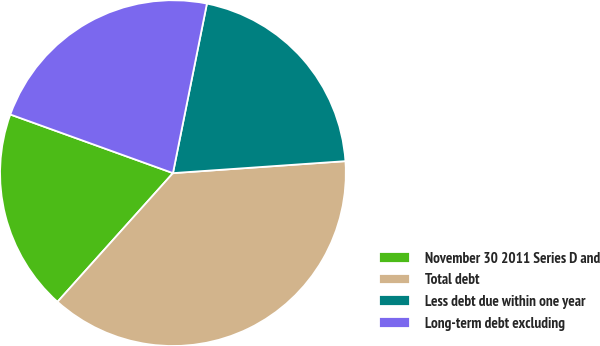Convert chart. <chart><loc_0><loc_0><loc_500><loc_500><pie_chart><fcel>November 30 2011 Series D and<fcel>Total debt<fcel>Less debt due within one year<fcel>Long-term debt excluding<nl><fcel>18.87%<fcel>37.74%<fcel>20.75%<fcel>22.64%<nl></chart> 